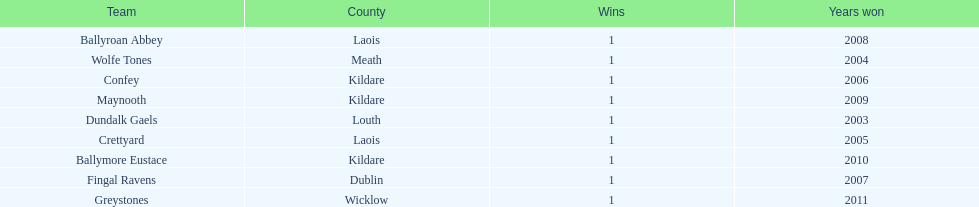What is the number of wins for each team 1. 